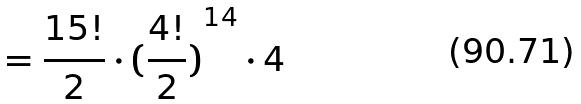Convert formula to latex. <formula><loc_0><loc_0><loc_500><loc_500>= \frac { 1 5 ! } { 2 } \cdot { ( \frac { 4 ! } { 2 } ) } ^ { 1 4 } \cdot 4</formula> 